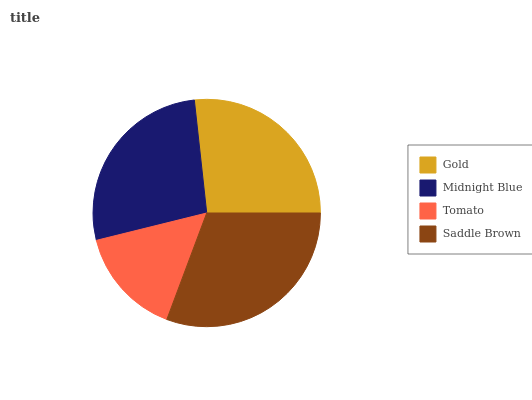Is Tomato the minimum?
Answer yes or no. Yes. Is Saddle Brown the maximum?
Answer yes or no. Yes. Is Midnight Blue the minimum?
Answer yes or no. No. Is Midnight Blue the maximum?
Answer yes or no. No. Is Midnight Blue greater than Gold?
Answer yes or no. Yes. Is Gold less than Midnight Blue?
Answer yes or no. Yes. Is Gold greater than Midnight Blue?
Answer yes or no. No. Is Midnight Blue less than Gold?
Answer yes or no. No. Is Midnight Blue the high median?
Answer yes or no. Yes. Is Gold the low median?
Answer yes or no. Yes. Is Gold the high median?
Answer yes or no. No. Is Tomato the low median?
Answer yes or no. No. 